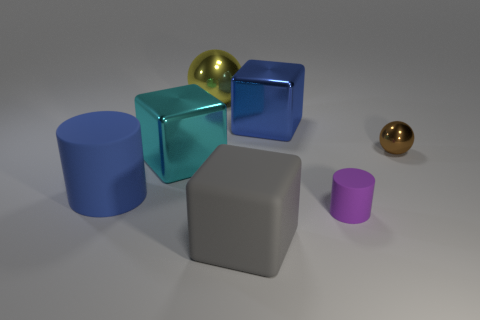How many things are small brown metallic balls or metal spheres that are left of the small purple object?
Give a very brief answer. 2. Is the number of objects that are right of the purple rubber cylinder less than the number of brown metallic objects?
Provide a short and direct response. No. There is a rubber cylinder right of the large blue thing behind the shiny sphere on the right side of the small purple object; what is its size?
Provide a succinct answer. Small. What color is the metallic thing that is to the left of the large gray block and in front of the large blue block?
Your answer should be very brief. Cyan. How many blocks are there?
Ensure brevity in your answer.  3. Is there any other thing that is the same size as the brown ball?
Your response must be concise. Yes. Do the blue cylinder and the big cyan object have the same material?
Your response must be concise. No. Do the ball that is left of the brown metal sphere and the thing in front of the purple matte thing have the same size?
Ensure brevity in your answer.  Yes. Are there fewer large metal cubes than small brown metal spheres?
Offer a terse response. No. What number of rubber objects are either gray blocks or large cylinders?
Provide a succinct answer. 2. 